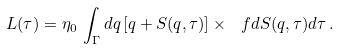<formula> <loc_0><loc_0><loc_500><loc_500>L ( \tau ) = \eta _ { 0 } \, \int _ { \Gamma } d q \, [ q + S ( q , \tau ) ] \times \ f { d S ( q , \tau ) } { d \tau } \, .</formula> 